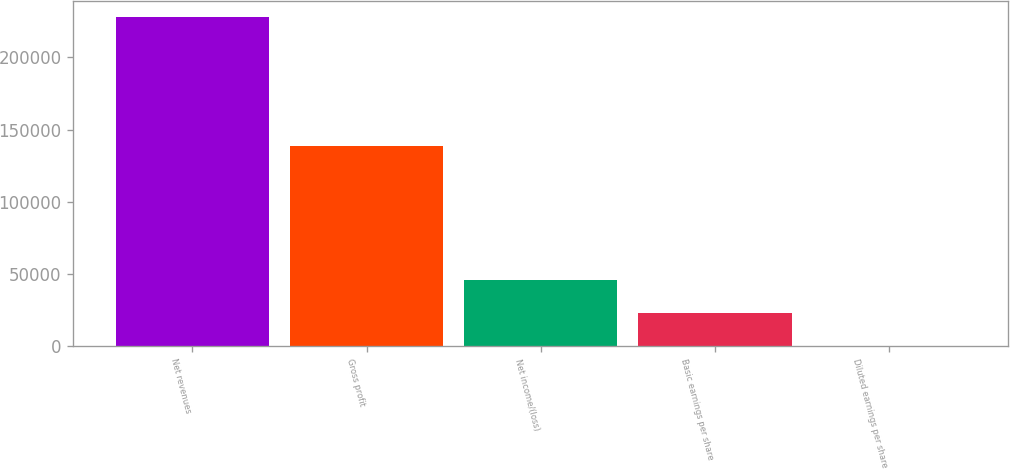Convert chart to OTSL. <chart><loc_0><loc_0><loc_500><loc_500><bar_chart><fcel>Net revenues<fcel>Gross profit<fcel>Net income/(loss)<fcel>Basic earnings per share<fcel>Diluted earnings per share<nl><fcel>227865<fcel>138943<fcel>45573.4<fcel>22787<fcel>0.51<nl></chart> 